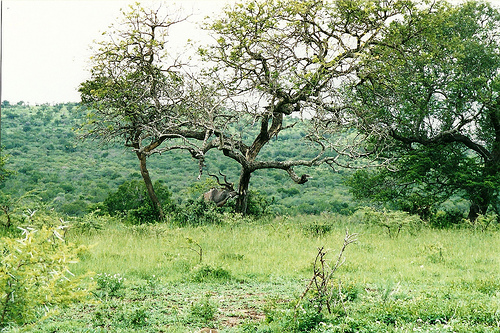<image>
Is the grass under the tree? Yes. The grass is positioned underneath the tree, with the tree above it in the vertical space. 